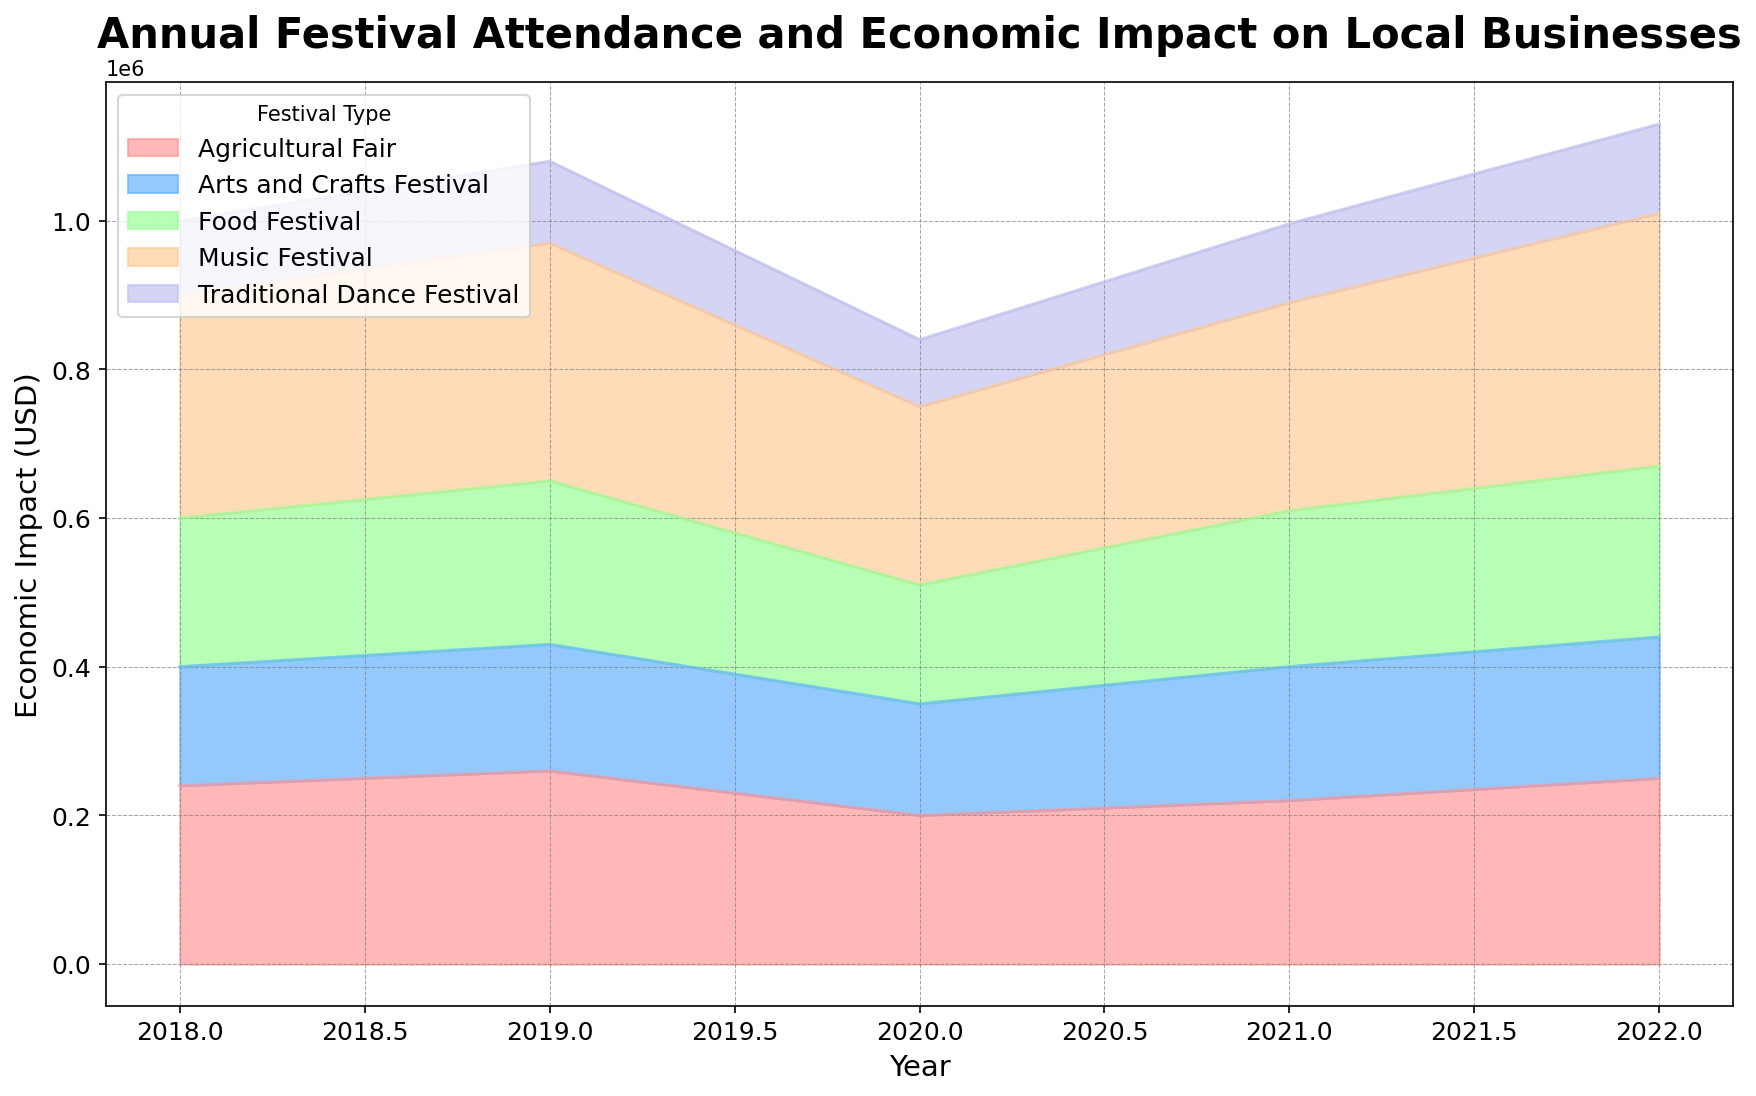What was the total economic impact from all festivals in 2022? To determine the total economic impact from all festivals in 2022, sum the economic impact values for each festival type: 340,000 (Music) + 230,000 (Food) + 190,000 (Arts and Crafts) + 250,000 (Agricultural) + 120,000 (Traditional Dance) = 1,130,000 USD
Answer: 1,130,000 USD Which festival type contributed the most to the economic impact in 2020? Refer to the 2020 data. Compare economic impacts: Music Festival (240,000 USD), Food Festival (160,000 USD), Arts and Crafts Festival (150,000 USD), Agricultural Fair (200,000 USD), Traditional Dance Festival (90,000 USD). The highest is Music Festival with 240,000 USD
Answer: Music Festival How did the economic impact of Food Festival change from 2019 to 2020? Check the economic impact for Food Festival in 2019 (220,000 USD) and 2020 (160,000 USD). Calculate the difference: 220,000 - 160,000 = 60,000 USD reduction
Answer: Reduced by 60,000 USD Which year had the highest total economic impact from the given festivals? Sum the economic impacts for all festival types by year and compare: 2018, 2019, 2020, 2021, 2022. The year with the highest total is determined by summing: 2018 (1,000,000 USD), 2019 (1,080,000 USD), 2020 (840,000 USD), 2021 (996,000 USD), 2022 (1,130,000 USD). The highest total is in 2022
Answer: 2022 What is the average economic impact of the Arts and Crafts Festival from 2018 to 2022? Sum the economic impacts for Arts and Crafts Festival over the years and divide by the number of years: (160,000 + 170,000 + 150,000 + 180,000 + 190,000) / 5 = 170,000 USD
Answer: 170,000 USD Which festival type saw the greatest increase in economic impact between 2021 and 2022? Calculate the difference in economic impact for each festival type from 2021 to 2022: Music (340,000 - 280,000 = 60,000 USD), Food (230,000 - 210,000 = 20,000 USD), Arts and Crafts (190,000 - 180,000 = 10,000 USD), Agricultural (250,000 - 220,000 = 30,000 USD), Traditional Dance (120,000 - 106,000 = 14,000 USD). The greatest increase is Music Festival with an increase of 60,000 USD
Answer: Music Festival In which year did the Traditional Dance Festival have its lowest economic impact? Review the economic impact values for Traditional Dance Festival by year: 2018 (100,000 USD), 2019 (110,000 USD), 2020 (90,000 USD), 2021 (106,000 USD), 2022 (120,000 USD). The lowest value is in 2020
Answer: 2020 How much did the attendance for the Agricultural Fair increase from 2020 to 2022? Check Agricultural Fair attendance in 2020 (10,000) and 2022 (12,500). Calculate the difference: 12,500 - 10,000 = 2,500 increase in attendance
Answer: Increased by 2,500 How does the height of the area for the Music Festival in 2021 compare visually to the same festival in 2018? Observe the height of the filled area for Music Festival in 2021 and 2018. The height in 2021 (280,000 USD) is visually higher compared to that in 2018 (300,000 USD), but slightly reduced in 2021
Answer: Slightly reduced in 2021 Combining the economic impact from Music Festival and Food Festival, which year had the highest combined impact? Sum the economic impacts of Music Festival and Food Festival for each year: 2018 (300,000 + 200,000 = 500,000 USD), 2019 (320,000 + 220,000 = 540,000 USD), 2020 (240,000 + 160,000 = 400,000 USD), 2021 (280,000 + 210,000 = 490,000 USD), 2022 (340,000 + 230,000 = 570,000 USD). The highest combined impact is in 2022 with 570,000 USD
Answer: 2022 